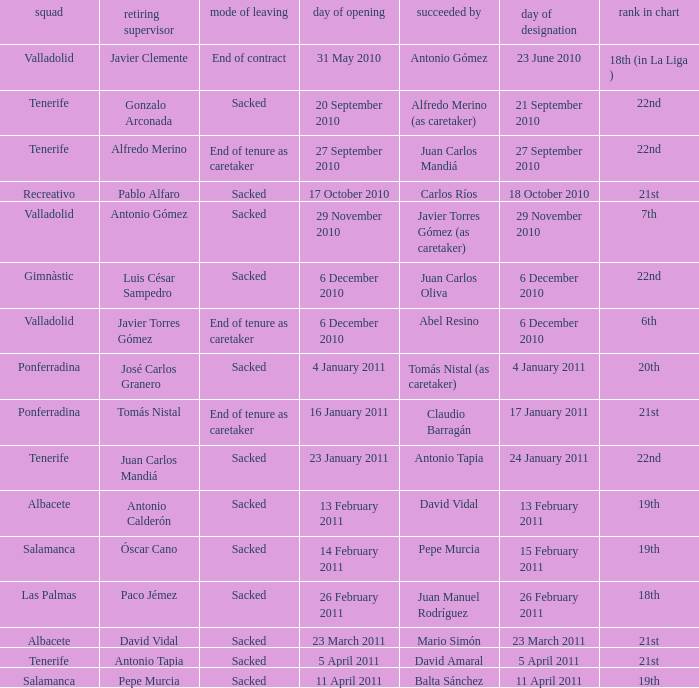Can you parse all the data within this table? {'header': ['squad', 'retiring supervisor', 'mode of leaving', 'day of opening', 'succeeded by', 'day of designation', 'rank in chart'], 'rows': [['Valladolid', 'Javier Clemente', 'End of contract', '31 May 2010', 'Antonio Gómez', '23 June 2010', '18th (in La Liga )'], ['Tenerife', 'Gonzalo Arconada', 'Sacked', '20 September 2010', 'Alfredo Merino (as caretaker)', '21 September 2010', '22nd'], ['Tenerife', 'Alfredo Merino', 'End of tenure as caretaker', '27 September 2010', 'Juan Carlos Mandiá', '27 September 2010', '22nd'], ['Recreativo', 'Pablo Alfaro', 'Sacked', '17 October 2010', 'Carlos Ríos', '18 October 2010', '21st'], ['Valladolid', 'Antonio Gómez', 'Sacked', '29 November 2010', 'Javier Torres Gómez (as caretaker)', '29 November 2010', '7th'], ['Gimnàstic', 'Luis César Sampedro', 'Sacked', '6 December 2010', 'Juan Carlos Oliva', '6 December 2010', '22nd'], ['Valladolid', 'Javier Torres Gómez', 'End of tenure as caretaker', '6 December 2010', 'Abel Resino', '6 December 2010', '6th'], ['Ponferradina', 'José Carlos Granero', 'Sacked', '4 January 2011', 'Tomás Nistal (as caretaker)', '4 January 2011', '20th'], ['Ponferradina', 'Tomás Nistal', 'End of tenure as caretaker', '16 January 2011', 'Claudio Barragán', '17 January 2011', '21st'], ['Tenerife', 'Juan Carlos Mandiá', 'Sacked', '23 January 2011', 'Antonio Tapia', '24 January 2011', '22nd'], ['Albacete', 'Antonio Calderón', 'Sacked', '13 February 2011', 'David Vidal', '13 February 2011', '19th'], ['Salamanca', 'Óscar Cano', 'Sacked', '14 February 2011', 'Pepe Murcia', '15 February 2011', '19th'], ['Las Palmas', 'Paco Jémez', 'Sacked', '26 February 2011', 'Juan Manuel Rodríguez', '26 February 2011', '18th'], ['Albacete', 'David Vidal', 'Sacked', '23 March 2011', 'Mario Simón', '23 March 2011', '21st'], ['Tenerife', 'Antonio Tapia', 'Sacked', '5 April 2011', 'David Amaral', '5 April 2011', '21st'], ['Salamanca', 'Pepe Murcia', 'Sacked', '11 April 2011', 'Balta Sánchez', '11 April 2011', '19th']]} What was the manner of departure for the appointment date of 21 september 2010 Sacked. 